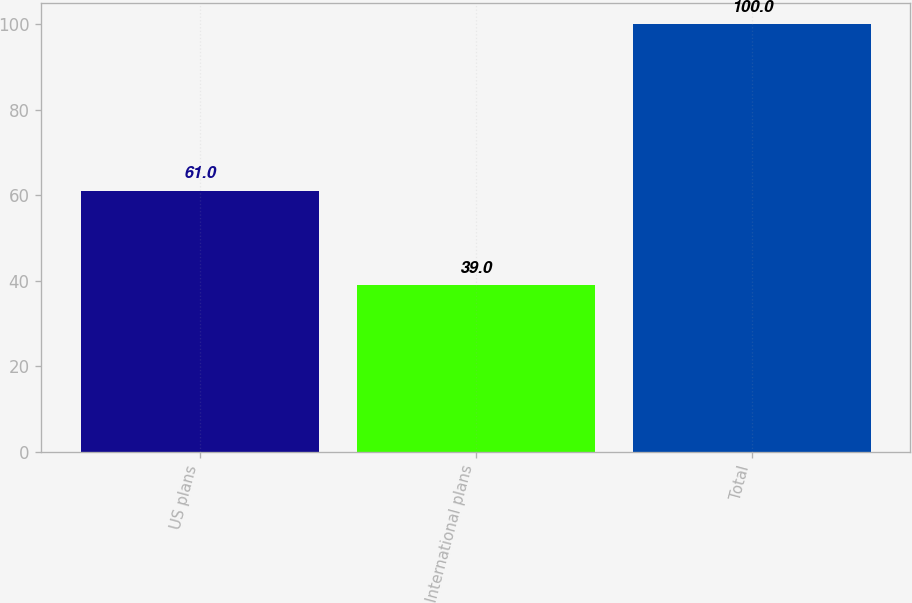Convert chart to OTSL. <chart><loc_0><loc_0><loc_500><loc_500><bar_chart><fcel>US plans<fcel>International plans<fcel>Total<nl><fcel>61<fcel>39<fcel>100<nl></chart> 